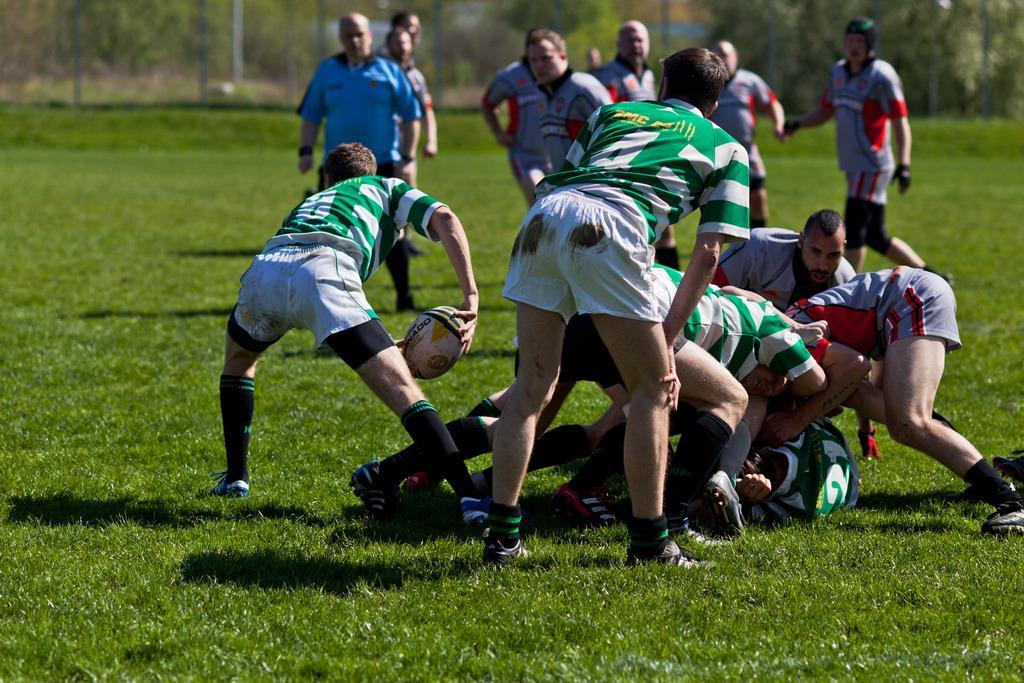Could you give a brief overview of what you see in this image? As we can see in the image there are few people playing on grass with a boll and in the background there are trees. 